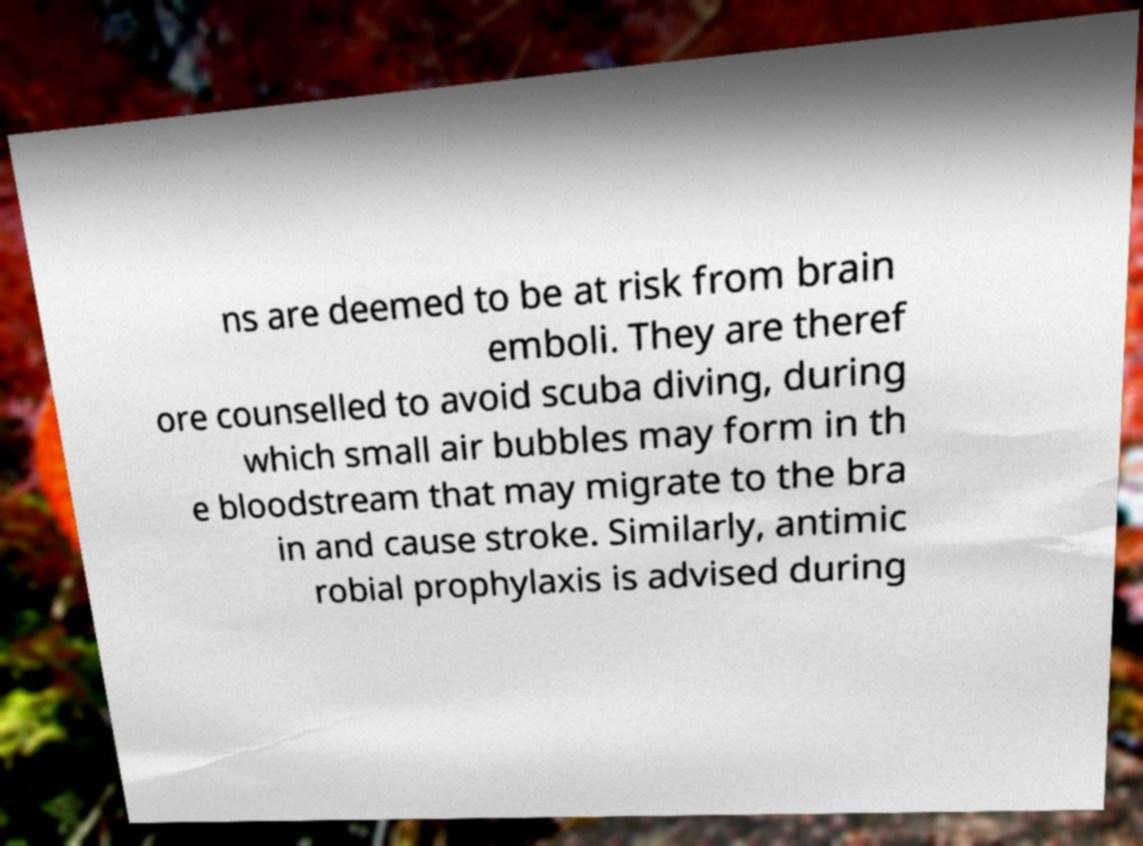Could you extract and type out the text from this image? ns are deemed to be at risk from brain emboli. They are theref ore counselled to avoid scuba diving, during which small air bubbles may form in th e bloodstream that may migrate to the bra in and cause stroke. Similarly, antimic robial prophylaxis is advised during 